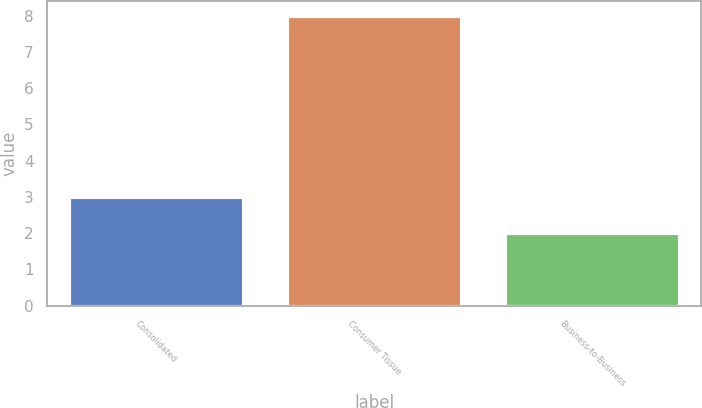<chart> <loc_0><loc_0><loc_500><loc_500><bar_chart><fcel>Consolidated<fcel>Consumer Tissue<fcel>Business-to-Business<nl><fcel>3<fcel>8<fcel>2<nl></chart> 